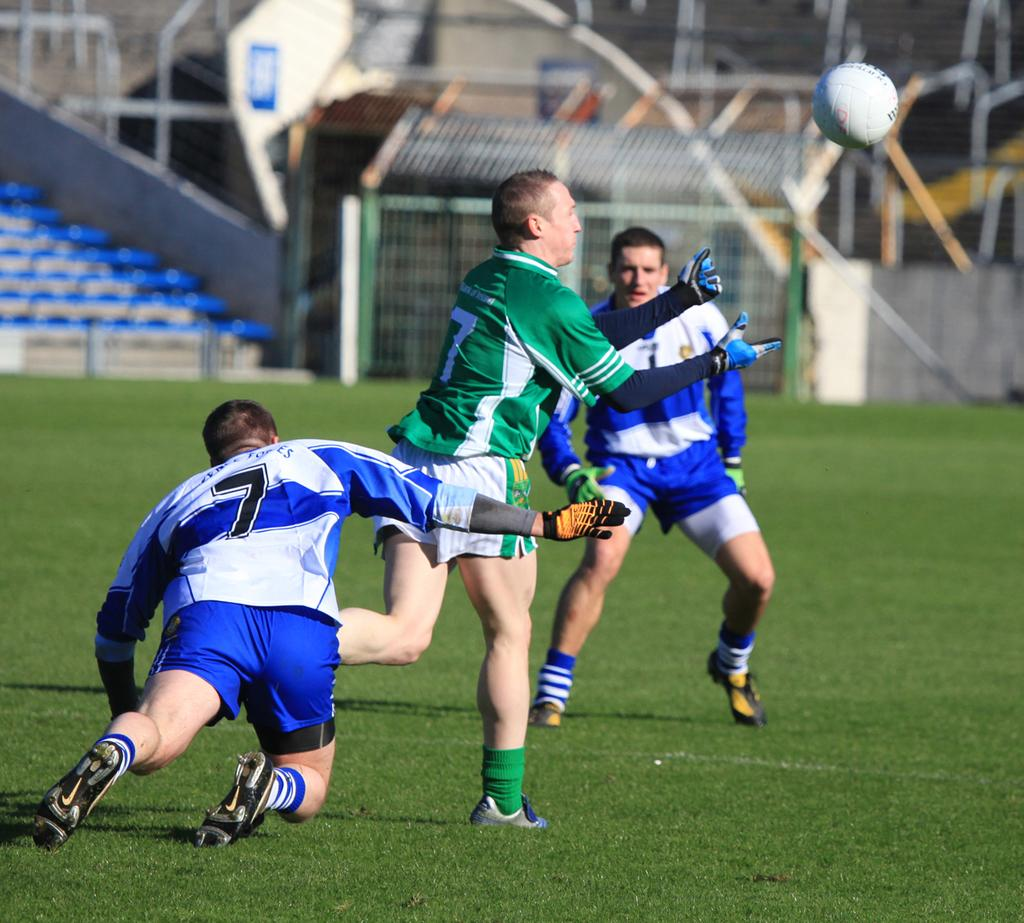<image>
Describe the image concisely. two soccer teams on a field, include blue team 7 and green team 7 